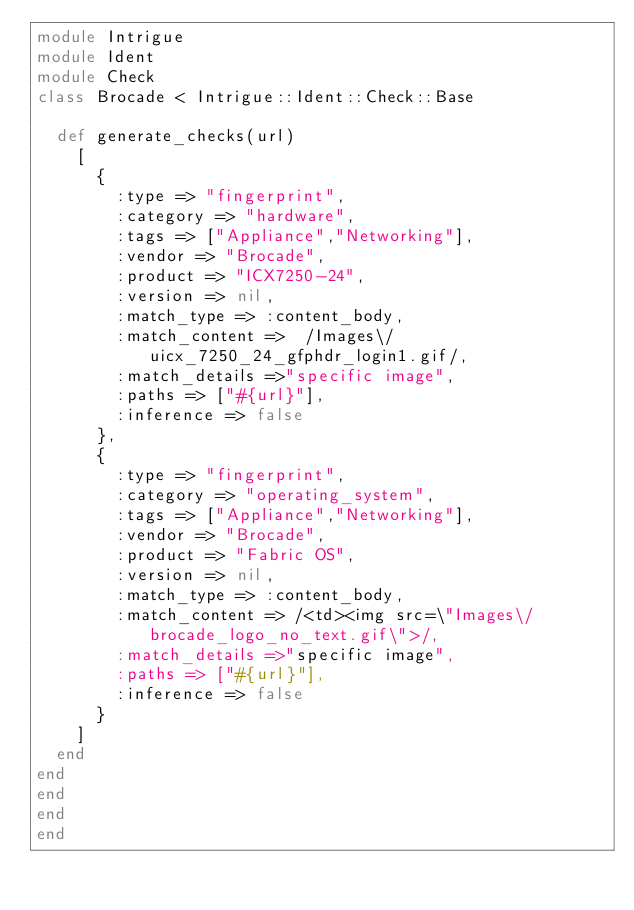Convert code to text. <code><loc_0><loc_0><loc_500><loc_500><_Ruby_>module Intrigue
module Ident
module Check
class Brocade < Intrigue::Ident::Check::Base

  def generate_checks(url)
    [
      {
        :type => "fingerprint",
        :category => "hardware",
        :tags => ["Appliance","Networking"],
        :vendor => "Brocade",
        :product => "ICX7250-24",
        :version => nil,
        :match_type => :content_body,
        :match_content =>  /Images\/uicx_7250_24_gfphdr_login1.gif/,
        :match_details =>"specific image",
        :paths => ["#{url}"],
        :inference => false
      },
      {
        :type => "fingerprint",
        :category => "operating_system",
        :tags => ["Appliance","Networking"],
        :vendor => "Brocade",
        :product => "Fabric OS",
        :version => nil,
        :match_type => :content_body,
        :match_content => /<td><img src=\"Images\/brocade_logo_no_text.gif\">/,
        :match_details =>"specific image",
        :paths => ["#{url}"],
        :inference => false
      }
    ]
  end
end
end
end
end
</code> 